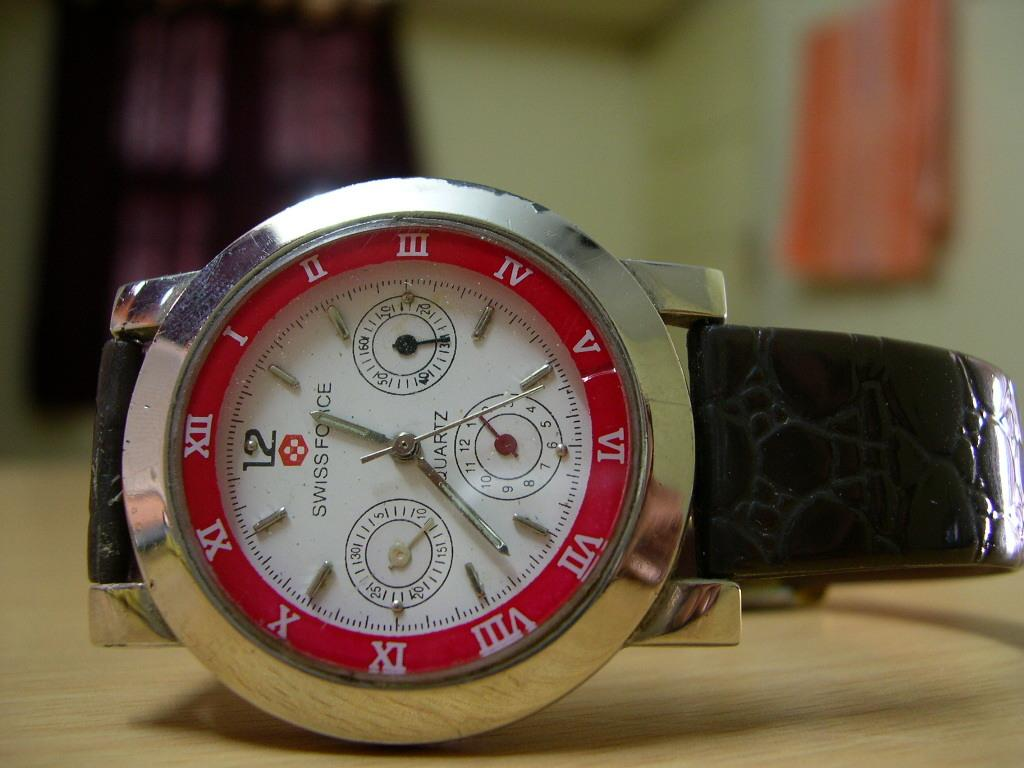<image>
Provide a brief description of the given image. A Swissforce watch has the time after 1:35. 